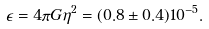<formula> <loc_0><loc_0><loc_500><loc_500>\epsilon = 4 \pi G \eta ^ { 2 } = ( 0 . 8 \pm 0 . 4 ) 1 0 ^ { - 5 } .</formula> 